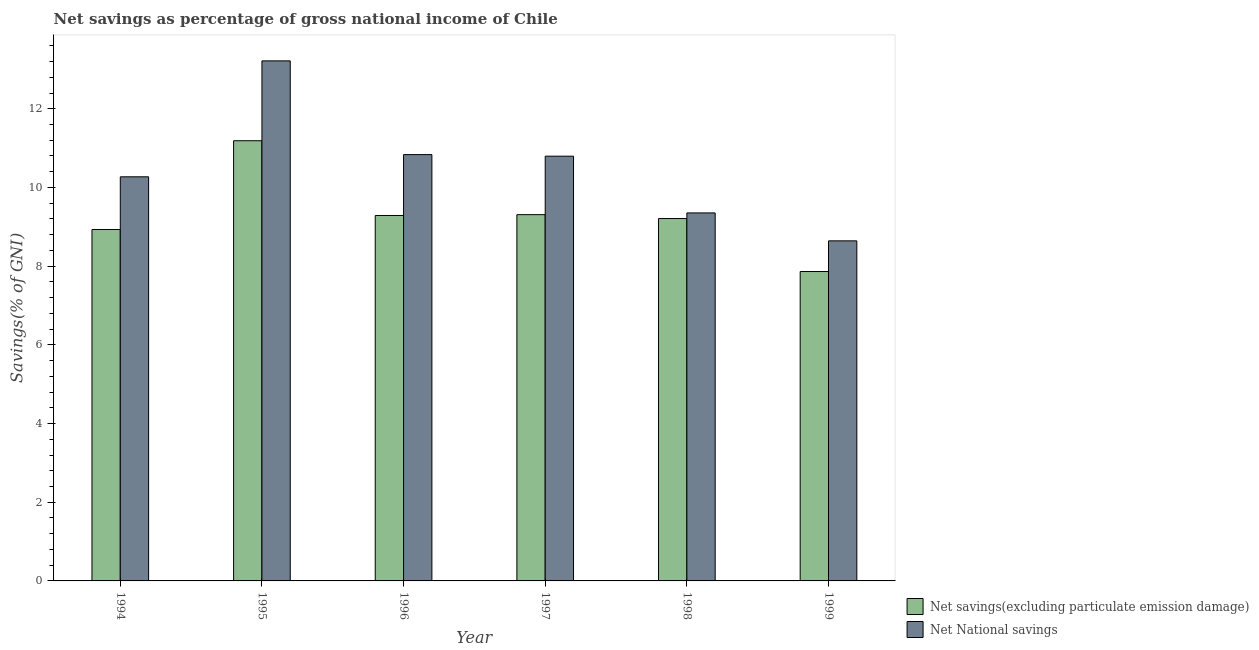How many different coloured bars are there?
Provide a succinct answer. 2. How many groups of bars are there?
Your response must be concise. 6. How many bars are there on the 6th tick from the right?
Provide a short and direct response. 2. What is the net national savings in 1998?
Make the answer very short. 9.35. Across all years, what is the maximum net savings(excluding particulate emission damage)?
Give a very brief answer. 11.19. Across all years, what is the minimum net national savings?
Make the answer very short. 8.64. In which year was the net national savings maximum?
Your response must be concise. 1995. In which year was the net savings(excluding particulate emission damage) minimum?
Give a very brief answer. 1999. What is the total net savings(excluding particulate emission damage) in the graph?
Offer a very short reply. 55.79. What is the difference between the net savings(excluding particulate emission damage) in 1994 and that in 1997?
Ensure brevity in your answer.  -0.38. What is the difference between the net savings(excluding particulate emission damage) in 1997 and the net national savings in 1995?
Your response must be concise. -1.88. What is the average net savings(excluding particulate emission damage) per year?
Give a very brief answer. 9.3. In the year 1997, what is the difference between the net national savings and net savings(excluding particulate emission damage)?
Make the answer very short. 0. What is the ratio of the net savings(excluding particulate emission damage) in 1995 to that in 1997?
Ensure brevity in your answer.  1.2. Is the difference between the net savings(excluding particulate emission damage) in 1994 and 1995 greater than the difference between the net national savings in 1994 and 1995?
Offer a very short reply. No. What is the difference between the highest and the second highest net national savings?
Keep it short and to the point. 2.38. What is the difference between the highest and the lowest net national savings?
Ensure brevity in your answer.  4.57. What does the 1st bar from the left in 1995 represents?
Offer a very short reply. Net savings(excluding particulate emission damage). What does the 2nd bar from the right in 1997 represents?
Keep it short and to the point. Net savings(excluding particulate emission damage). Are the values on the major ticks of Y-axis written in scientific E-notation?
Your answer should be compact. No. Does the graph contain any zero values?
Provide a short and direct response. No. How many legend labels are there?
Provide a short and direct response. 2. How are the legend labels stacked?
Provide a succinct answer. Vertical. What is the title of the graph?
Provide a succinct answer. Net savings as percentage of gross national income of Chile. What is the label or title of the X-axis?
Your answer should be very brief. Year. What is the label or title of the Y-axis?
Provide a short and direct response. Savings(% of GNI). What is the Savings(% of GNI) of Net savings(excluding particulate emission damage) in 1994?
Keep it short and to the point. 8.93. What is the Savings(% of GNI) in Net National savings in 1994?
Your answer should be very brief. 10.27. What is the Savings(% of GNI) in Net savings(excluding particulate emission damage) in 1995?
Offer a terse response. 11.19. What is the Savings(% of GNI) of Net National savings in 1995?
Keep it short and to the point. 13.22. What is the Savings(% of GNI) of Net savings(excluding particulate emission damage) in 1996?
Make the answer very short. 9.29. What is the Savings(% of GNI) in Net National savings in 1996?
Offer a terse response. 10.83. What is the Savings(% of GNI) of Net savings(excluding particulate emission damage) in 1997?
Your answer should be very brief. 9.31. What is the Savings(% of GNI) in Net National savings in 1997?
Your answer should be compact. 10.79. What is the Savings(% of GNI) of Net savings(excluding particulate emission damage) in 1998?
Give a very brief answer. 9.21. What is the Savings(% of GNI) of Net National savings in 1998?
Your response must be concise. 9.35. What is the Savings(% of GNI) in Net savings(excluding particulate emission damage) in 1999?
Your answer should be compact. 7.86. What is the Savings(% of GNI) in Net National savings in 1999?
Your answer should be compact. 8.64. Across all years, what is the maximum Savings(% of GNI) in Net savings(excluding particulate emission damage)?
Give a very brief answer. 11.19. Across all years, what is the maximum Savings(% of GNI) in Net National savings?
Offer a very short reply. 13.22. Across all years, what is the minimum Savings(% of GNI) in Net savings(excluding particulate emission damage)?
Provide a short and direct response. 7.86. Across all years, what is the minimum Savings(% of GNI) in Net National savings?
Your answer should be very brief. 8.64. What is the total Savings(% of GNI) in Net savings(excluding particulate emission damage) in the graph?
Offer a very short reply. 55.79. What is the total Savings(% of GNI) of Net National savings in the graph?
Give a very brief answer. 63.11. What is the difference between the Savings(% of GNI) in Net savings(excluding particulate emission damage) in 1994 and that in 1995?
Offer a terse response. -2.26. What is the difference between the Savings(% of GNI) in Net National savings in 1994 and that in 1995?
Provide a succinct answer. -2.95. What is the difference between the Savings(% of GNI) in Net savings(excluding particulate emission damage) in 1994 and that in 1996?
Provide a succinct answer. -0.36. What is the difference between the Savings(% of GNI) of Net National savings in 1994 and that in 1996?
Your answer should be compact. -0.56. What is the difference between the Savings(% of GNI) of Net savings(excluding particulate emission damage) in 1994 and that in 1997?
Give a very brief answer. -0.38. What is the difference between the Savings(% of GNI) in Net National savings in 1994 and that in 1997?
Give a very brief answer. -0.52. What is the difference between the Savings(% of GNI) in Net savings(excluding particulate emission damage) in 1994 and that in 1998?
Give a very brief answer. -0.28. What is the difference between the Savings(% of GNI) in Net National savings in 1994 and that in 1998?
Make the answer very short. 0.92. What is the difference between the Savings(% of GNI) of Net savings(excluding particulate emission damage) in 1994 and that in 1999?
Make the answer very short. 1.07. What is the difference between the Savings(% of GNI) in Net National savings in 1994 and that in 1999?
Give a very brief answer. 1.63. What is the difference between the Savings(% of GNI) of Net savings(excluding particulate emission damage) in 1995 and that in 1996?
Keep it short and to the point. 1.9. What is the difference between the Savings(% of GNI) of Net National savings in 1995 and that in 1996?
Your response must be concise. 2.38. What is the difference between the Savings(% of GNI) of Net savings(excluding particulate emission damage) in 1995 and that in 1997?
Offer a terse response. 1.88. What is the difference between the Savings(% of GNI) in Net National savings in 1995 and that in 1997?
Give a very brief answer. 2.42. What is the difference between the Savings(% of GNI) of Net savings(excluding particulate emission damage) in 1995 and that in 1998?
Provide a succinct answer. 1.98. What is the difference between the Savings(% of GNI) of Net National savings in 1995 and that in 1998?
Keep it short and to the point. 3.86. What is the difference between the Savings(% of GNI) in Net savings(excluding particulate emission damage) in 1995 and that in 1999?
Provide a short and direct response. 3.32. What is the difference between the Savings(% of GNI) of Net National savings in 1995 and that in 1999?
Your answer should be very brief. 4.57. What is the difference between the Savings(% of GNI) in Net savings(excluding particulate emission damage) in 1996 and that in 1997?
Offer a terse response. -0.02. What is the difference between the Savings(% of GNI) of Net National savings in 1996 and that in 1997?
Make the answer very short. 0.04. What is the difference between the Savings(% of GNI) of Net savings(excluding particulate emission damage) in 1996 and that in 1998?
Your answer should be compact. 0.08. What is the difference between the Savings(% of GNI) of Net National savings in 1996 and that in 1998?
Give a very brief answer. 1.48. What is the difference between the Savings(% of GNI) in Net savings(excluding particulate emission damage) in 1996 and that in 1999?
Provide a short and direct response. 1.42. What is the difference between the Savings(% of GNI) in Net National savings in 1996 and that in 1999?
Your response must be concise. 2.19. What is the difference between the Savings(% of GNI) in Net savings(excluding particulate emission damage) in 1997 and that in 1998?
Keep it short and to the point. 0.1. What is the difference between the Savings(% of GNI) of Net National savings in 1997 and that in 1998?
Make the answer very short. 1.44. What is the difference between the Savings(% of GNI) in Net savings(excluding particulate emission damage) in 1997 and that in 1999?
Your response must be concise. 1.45. What is the difference between the Savings(% of GNI) of Net National savings in 1997 and that in 1999?
Keep it short and to the point. 2.15. What is the difference between the Savings(% of GNI) of Net savings(excluding particulate emission damage) in 1998 and that in 1999?
Your answer should be compact. 1.35. What is the difference between the Savings(% of GNI) in Net National savings in 1998 and that in 1999?
Offer a very short reply. 0.71. What is the difference between the Savings(% of GNI) of Net savings(excluding particulate emission damage) in 1994 and the Savings(% of GNI) of Net National savings in 1995?
Provide a succinct answer. -4.29. What is the difference between the Savings(% of GNI) in Net savings(excluding particulate emission damage) in 1994 and the Savings(% of GNI) in Net National savings in 1996?
Your response must be concise. -1.9. What is the difference between the Savings(% of GNI) in Net savings(excluding particulate emission damage) in 1994 and the Savings(% of GNI) in Net National savings in 1997?
Your answer should be very brief. -1.86. What is the difference between the Savings(% of GNI) of Net savings(excluding particulate emission damage) in 1994 and the Savings(% of GNI) of Net National savings in 1998?
Your response must be concise. -0.42. What is the difference between the Savings(% of GNI) of Net savings(excluding particulate emission damage) in 1994 and the Savings(% of GNI) of Net National savings in 1999?
Keep it short and to the point. 0.29. What is the difference between the Savings(% of GNI) in Net savings(excluding particulate emission damage) in 1995 and the Savings(% of GNI) in Net National savings in 1996?
Provide a succinct answer. 0.35. What is the difference between the Savings(% of GNI) in Net savings(excluding particulate emission damage) in 1995 and the Savings(% of GNI) in Net National savings in 1997?
Offer a terse response. 0.39. What is the difference between the Savings(% of GNI) in Net savings(excluding particulate emission damage) in 1995 and the Savings(% of GNI) in Net National savings in 1998?
Make the answer very short. 1.83. What is the difference between the Savings(% of GNI) in Net savings(excluding particulate emission damage) in 1995 and the Savings(% of GNI) in Net National savings in 1999?
Ensure brevity in your answer.  2.54. What is the difference between the Savings(% of GNI) of Net savings(excluding particulate emission damage) in 1996 and the Savings(% of GNI) of Net National savings in 1997?
Your answer should be very brief. -1.51. What is the difference between the Savings(% of GNI) in Net savings(excluding particulate emission damage) in 1996 and the Savings(% of GNI) in Net National savings in 1998?
Offer a terse response. -0.06. What is the difference between the Savings(% of GNI) in Net savings(excluding particulate emission damage) in 1996 and the Savings(% of GNI) in Net National savings in 1999?
Give a very brief answer. 0.65. What is the difference between the Savings(% of GNI) in Net savings(excluding particulate emission damage) in 1997 and the Savings(% of GNI) in Net National savings in 1998?
Your answer should be compact. -0.04. What is the difference between the Savings(% of GNI) of Net savings(excluding particulate emission damage) in 1997 and the Savings(% of GNI) of Net National savings in 1999?
Ensure brevity in your answer.  0.67. What is the difference between the Savings(% of GNI) of Net savings(excluding particulate emission damage) in 1998 and the Savings(% of GNI) of Net National savings in 1999?
Your answer should be very brief. 0.57. What is the average Savings(% of GNI) of Net savings(excluding particulate emission damage) per year?
Ensure brevity in your answer.  9.3. What is the average Savings(% of GNI) in Net National savings per year?
Your answer should be very brief. 10.52. In the year 1994, what is the difference between the Savings(% of GNI) in Net savings(excluding particulate emission damage) and Savings(% of GNI) in Net National savings?
Your answer should be compact. -1.34. In the year 1995, what is the difference between the Savings(% of GNI) of Net savings(excluding particulate emission damage) and Savings(% of GNI) of Net National savings?
Your answer should be very brief. -2.03. In the year 1996, what is the difference between the Savings(% of GNI) of Net savings(excluding particulate emission damage) and Savings(% of GNI) of Net National savings?
Keep it short and to the point. -1.55. In the year 1997, what is the difference between the Savings(% of GNI) in Net savings(excluding particulate emission damage) and Savings(% of GNI) in Net National savings?
Provide a short and direct response. -1.49. In the year 1998, what is the difference between the Savings(% of GNI) of Net savings(excluding particulate emission damage) and Savings(% of GNI) of Net National savings?
Keep it short and to the point. -0.14. In the year 1999, what is the difference between the Savings(% of GNI) in Net savings(excluding particulate emission damage) and Savings(% of GNI) in Net National savings?
Your answer should be very brief. -0.78. What is the ratio of the Savings(% of GNI) in Net savings(excluding particulate emission damage) in 1994 to that in 1995?
Your answer should be compact. 0.8. What is the ratio of the Savings(% of GNI) of Net National savings in 1994 to that in 1995?
Offer a very short reply. 0.78. What is the ratio of the Savings(% of GNI) of Net savings(excluding particulate emission damage) in 1994 to that in 1996?
Make the answer very short. 0.96. What is the ratio of the Savings(% of GNI) in Net National savings in 1994 to that in 1996?
Offer a very short reply. 0.95. What is the ratio of the Savings(% of GNI) in Net savings(excluding particulate emission damage) in 1994 to that in 1997?
Ensure brevity in your answer.  0.96. What is the ratio of the Savings(% of GNI) of Net National savings in 1994 to that in 1997?
Give a very brief answer. 0.95. What is the ratio of the Savings(% of GNI) of Net savings(excluding particulate emission damage) in 1994 to that in 1998?
Your response must be concise. 0.97. What is the ratio of the Savings(% of GNI) of Net National savings in 1994 to that in 1998?
Keep it short and to the point. 1.1. What is the ratio of the Savings(% of GNI) in Net savings(excluding particulate emission damage) in 1994 to that in 1999?
Your answer should be very brief. 1.14. What is the ratio of the Savings(% of GNI) in Net National savings in 1994 to that in 1999?
Give a very brief answer. 1.19. What is the ratio of the Savings(% of GNI) of Net savings(excluding particulate emission damage) in 1995 to that in 1996?
Keep it short and to the point. 1.2. What is the ratio of the Savings(% of GNI) of Net National savings in 1995 to that in 1996?
Make the answer very short. 1.22. What is the ratio of the Savings(% of GNI) in Net savings(excluding particulate emission damage) in 1995 to that in 1997?
Offer a very short reply. 1.2. What is the ratio of the Savings(% of GNI) of Net National savings in 1995 to that in 1997?
Give a very brief answer. 1.22. What is the ratio of the Savings(% of GNI) of Net savings(excluding particulate emission damage) in 1995 to that in 1998?
Provide a short and direct response. 1.21. What is the ratio of the Savings(% of GNI) in Net National savings in 1995 to that in 1998?
Make the answer very short. 1.41. What is the ratio of the Savings(% of GNI) of Net savings(excluding particulate emission damage) in 1995 to that in 1999?
Ensure brevity in your answer.  1.42. What is the ratio of the Savings(% of GNI) of Net National savings in 1995 to that in 1999?
Provide a short and direct response. 1.53. What is the ratio of the Savings(% of GNI) of Net National savings in 1996 to that in 1997?
Offer a very short reply. 1. What is the ratio of the Savings(% of GNI) in Net savings(excluding particulate emission damage) in 1996 to that in 1998?
Offer a terse response. 1.01. What is the ratio of the Savings(% of GNI) of Net National savings in 1996 to that in 1998?
Your response must be concise. 1.16. What is the ratio of the Savings(% of GNI) of Net savings(excluding particulate emission damage) in 1996 to that in 1999?
Your answer should be very brief. 1.18. What is the ratio of the Savings(% of GNI) of Net National savings in 1996 to that in 1999?
Ensure brevity in your answer.  1.25. What is the ratio of the Savings(% of GNI) in Net savings(excluding particulate emission damage) in 1997 to that in 1998?
Offer a terse response. 1.01. What is the ratio of the Savings(% of GNI) in Net National savings in 1997 to that in 1998?
Your response must be concise. 1.15. What is the ratio of the Savings(% of GNI) of Net savings(excluding particulate emission damage) in 1997 to that in 1999?
Your response must be concise. 1.18. What is the ratio of the Savings(% of GNI) of Net National savings in 1997 to that in 1999?
Your answer should be very brief. 1.25. What is the ratio of the Savings(% of GNI) in Net savings(excluding particulate emission damage) in 1998 to that in 1999?
Your answer should be compact. 1.17. What is the ratio of the Savings(% of GNI) in Net National savings in 1998 to that in 1999?
Make the answer very short. 1.08. What is the difference between the highest and the second highest Savings(% of GNI) in Net savings(excluding particulate emission damage)?
Your response must be concise. 1.88. What is the difference between the highest and the second highest Savings(% of GNI) of Net National savings?
Offer a terse response. 2.38. What is the difference between the highest and the lowest Savings(% of GNI) in Net savings(excluding particulate emission damage)?
Provide a succinct answer. 3.32. What is the difference between the highest and the lowest Savings(% of GNI) of Net National savings?
Give a very brief answer. 4.57. 